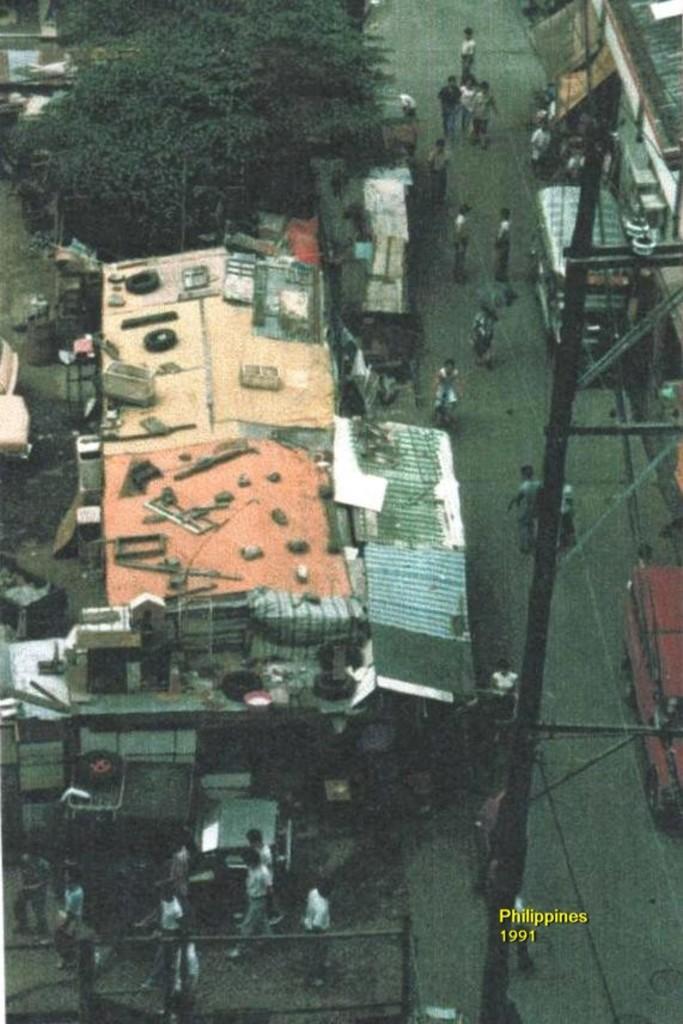Could you give a brief overview of what you see in this image? In the center of the image we can see two vehicles on the road. And we can see buildings, tires, trees, one pole, fence, few people are standing, few people are walking on the road and a few other objects. 